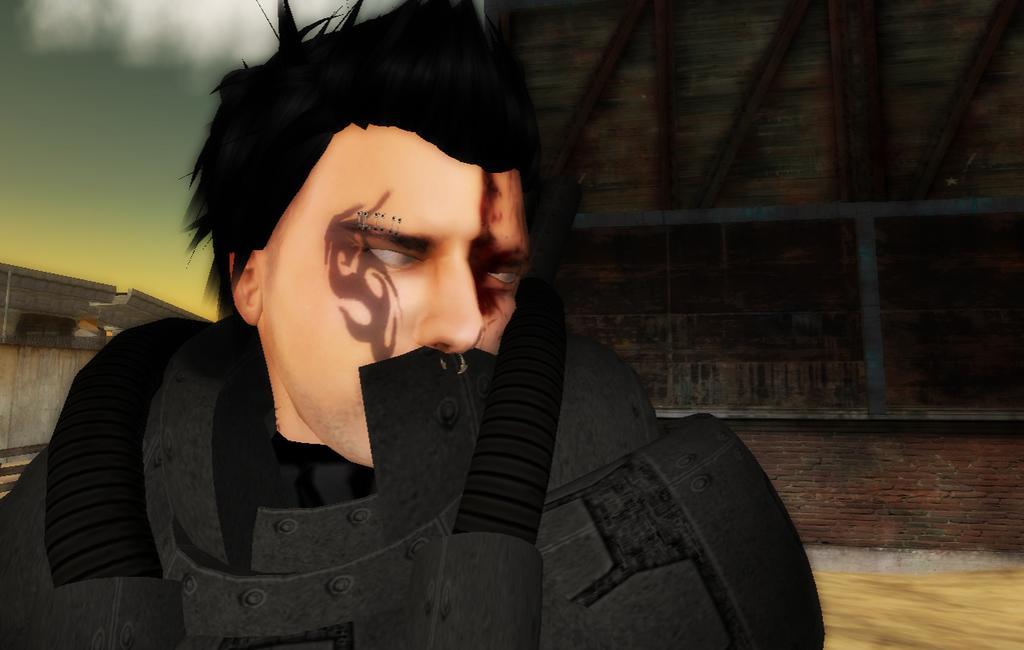Please provide a concise description of this image. In this image, we can see an animated picture. Here we can see a person. Background there is a brick wall and few objects are visible. 